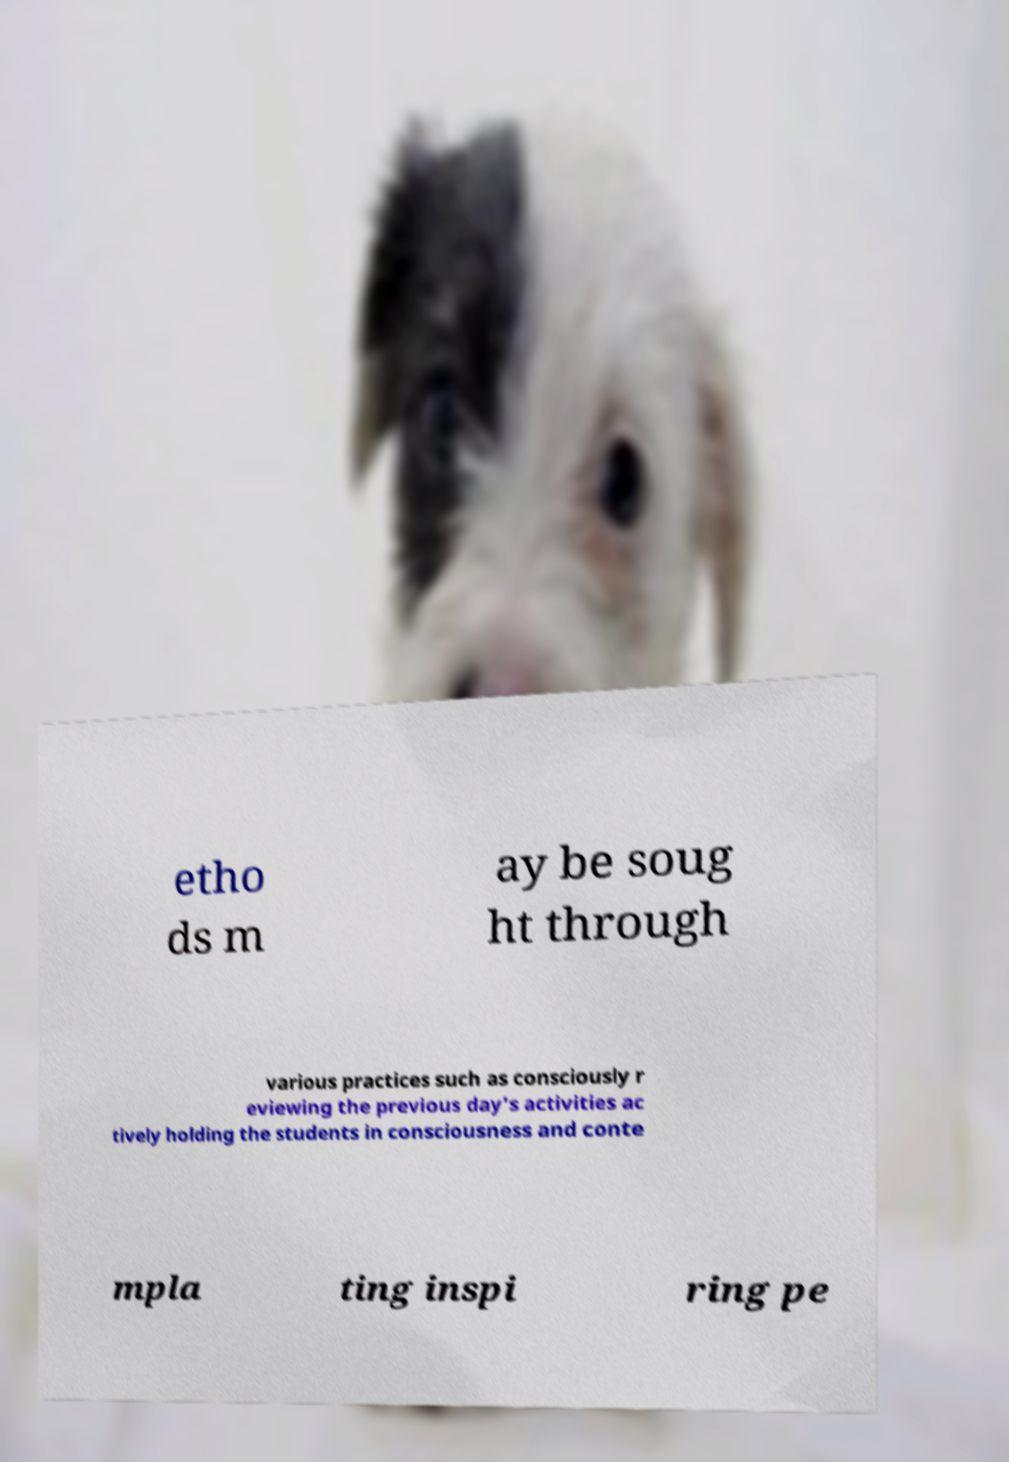Can you accurately transcribe the text from the provided image for me? etho ds m ay be soug ht through various practices such as consciously r eviewing the previous day's activities ac tively holding the students in consciousness and conte mpla ting inspi ring pe 